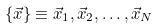Convert formula to latex. <formula><loc_0><loc_0><loc_500><loc_500>\{ \vec { x } \} \equiv \vec { x } _ { 1 } , \vec { x } _ { 2 } , \dots , \vec { x } _ { N }</formula> 